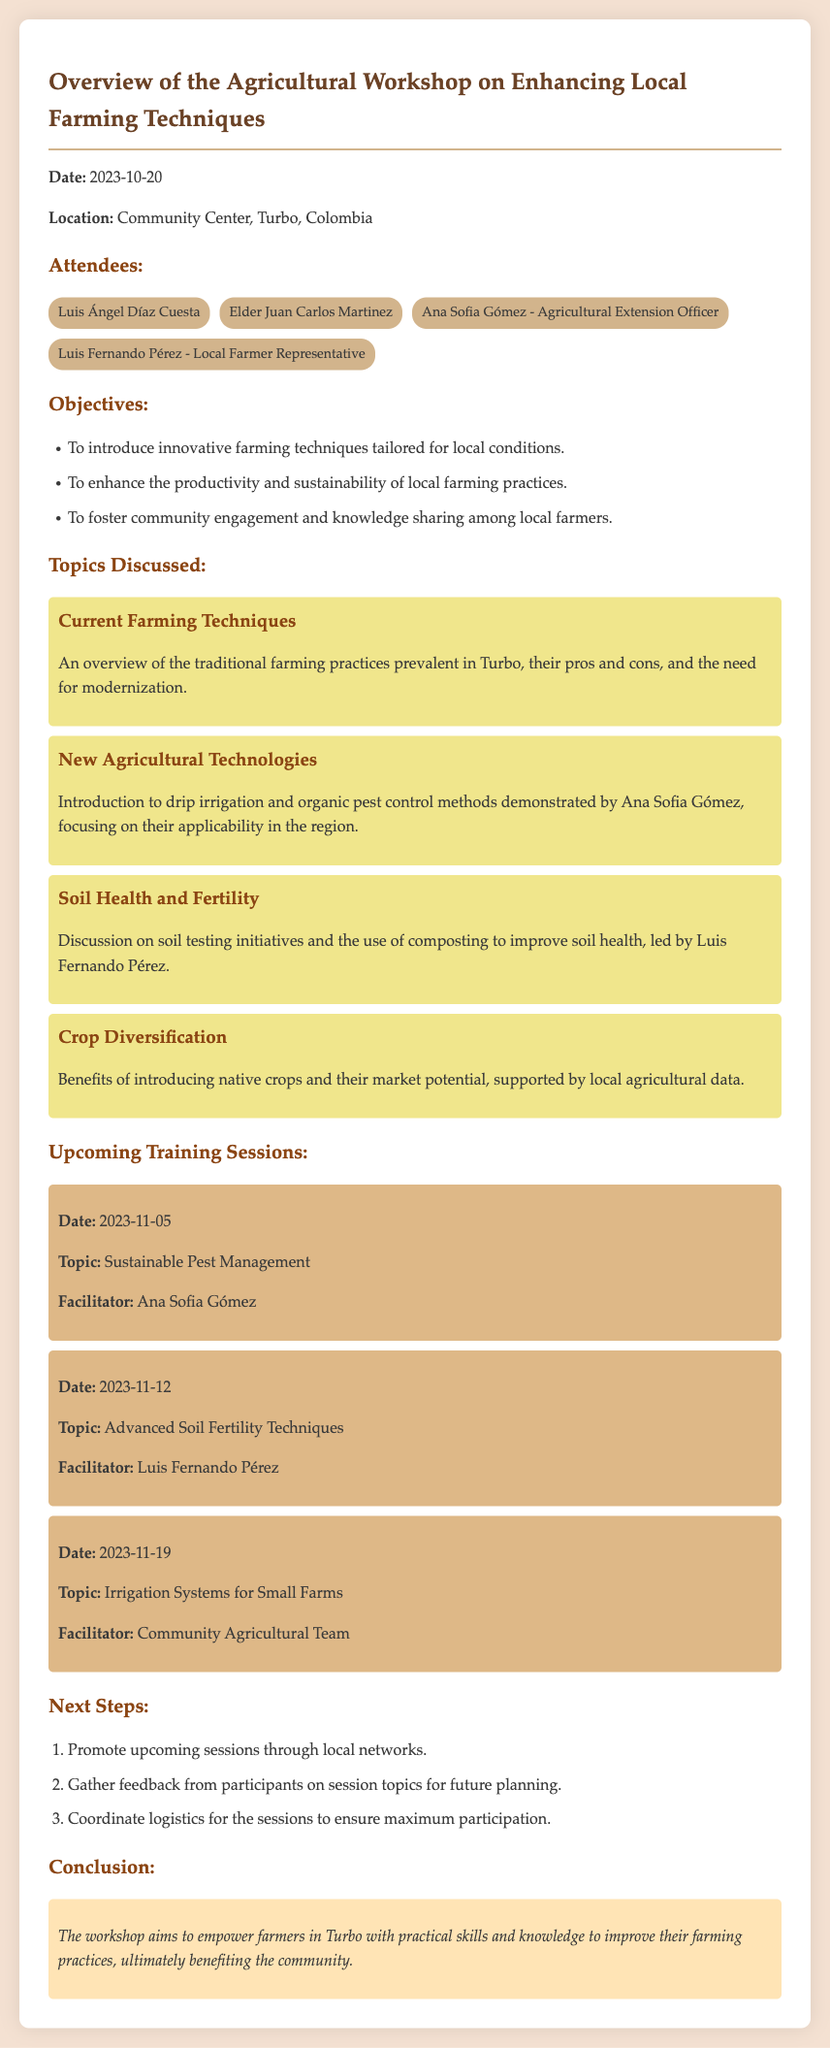What was the date of the workshop? The date of the workshop is specified in the document as 2023-10-20.
Answer: 2023-10-20 Who facilitated the session on Sustainable Pest Management? The document states that Ana Sofia Gómez facilitated the session on Sustainable Pest Management.
Answer: Ana Sofia Gómez What is one objective of the workshop? The document lists several objectives; one of them is to introduce innovative farming techniques tailored for local conditions.
Answer: Introduce innovative farming techniques What topic was discussed regarding soil health? The document mentions that the discussion on soil health was led by Luis Fernando Pérez and included soil testing initiatives and composting.
Answer: Soil testing initiatives and composting When is the next training session scheduled? The document provides a schedule for upcoming training sessions; the next one is on 2023-11-05.
Answer: 2023-11-05 How many attendees are listed in the document? The document lists a total of four attendees.
Answer: Four What was the location of the workshop? The workshop took place at the Community Center in Turbo, Colombia.
Answer: Community Center, Turbo, Colombia What conclusion does the document present? The conclusion indicates that the workshop aims to empower farmers in Turbo with practical skills and knowledge to improve their farming practices.
Answer: Empower farmers in Turbo with practical skills and knowledge 